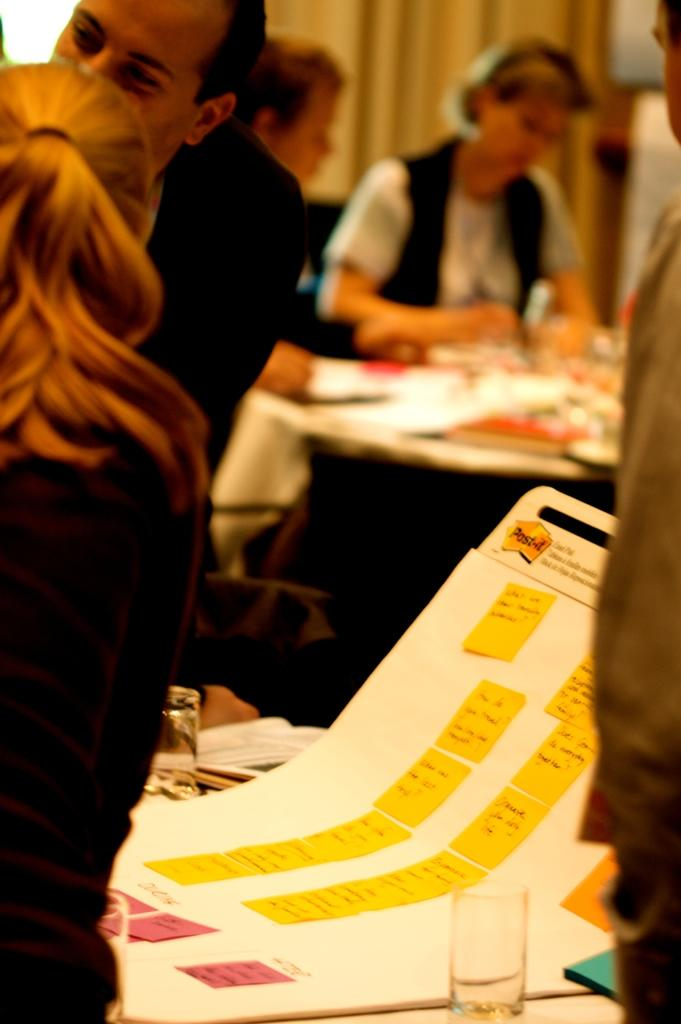Where was the image taken? The image was taken inside a room. Who or what can be seen in the image? There are people in the image. What furniture is present in the room? There is a table and chairs in the image. What is on the table? There is a chart, a glass, and books on the table. Who is the owner of the scissors in the image? There are no scissors present in the image. 